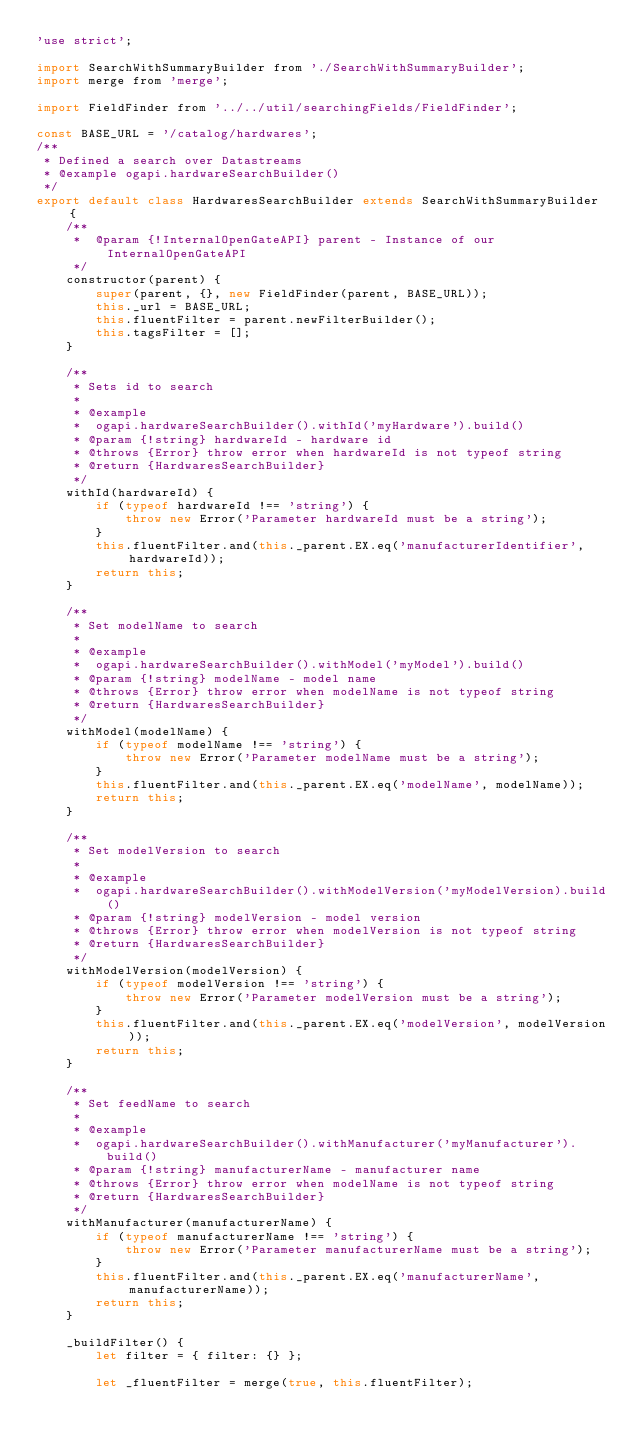Convert code to text. <code><loc_0><loc_0><loc_500><loc_500><_JavaScript_>'use strict';

import SearchWithSummaryBuilder from './SearchWithSummaryBuilder';
import merge from 'merge';

import FieldFinder from '../../util/searchingFields/FieldFinder';

const BASE_URL = '/catalog/hardwares';
/**
 * Defined a search over Datastreams	
 * @example ogapi.hardwareSearchBuilder()
 */
export default class HardwaresSearchBuilder extends SearchWithSummaryBuilder {
    /**
     *	@param {!InternalOpenGateAPI} parent - Instance of our InternalOpenGateAPI
     */
    constructor(parent) {
        super(parent, {}, new FieldFinder(parent, BASE_URL));
        this._url = BASE_URL;
        this.fluentFilter = parent.newFilterBuilder();
        this.tagsFilter = [];
    }

    /**
     * Sets id to search
     *
     * @example
     *	ogapi.hardwareSearchBuilder().withId('myHardware').build()
     * @param {!string} hardwareId - hardware id
     * @throws {Error} throw error when hardwareId is not typeof string
     * @return {HardwaresSearchBuilder} 
     */
    withId(hardwareId) {
        if (typeof hardwareId !== 'string') {
            throw new Error('Parameter hardwareId must be a string');
        }
        this.fluentFilter.and(this._parent.EX.eq('manufacturerIdentifier', hardwareId));
        return this;
    }

    /**
     * Set modelName to search
     *
     * @example
     *	ogapi.hardwareSearchBuilder().withModel('myModel').build()
     * @param {!string} modelName - model name
     * @throws {Error} throw error when modelName is not typeof string
     * @return {HardwaresSearchBuilder} 
     */
    withModel(modelName) {
        if (typeof modelName !== 'string') {
            throw new Error('Parameter modelName must be a string');
        }
        this.fluentFilter.and(this._parent.EX.eq('modelName', modelName));
        return this;
    }

    /**
     * Set modelVersion to search
     *
     * @example
     *	ogapi.hardwareSearchBuilder().withModelVersion('myModelVersion).build()
     * @param {!string} modelVersion - model version
     * @throws {Error} throw error when modelVersion is not typeof string
     * @return {HardwaresSearchBuilder} 
     */
    withModelVersion(modelVersion) {
        if (typeof modelVersion !== 'string') {
            throw new Error('Parameter modelVersion must be a string');
        }
        this.fluentFilter.and(this._parent.EX.eq('modelVersion', modelVersion));
        return this;
    }

    /**
     * Set feedName to search
     *
     * @example
     *	ogapi.hardwareSearchBuilder().withManufacturer('myManufacturer').build()
     * @param {!string} manufacturerName - manufacturer name
     * @throws {Error} throw error when modelName is not typeof string
     * @return {HardwaresSearchBuilder} 
     */
    withManufacturer(manufacturerName) {
        if (typeof manufacturerName !== 'string') {
            throw new Error('Parameter manufacturerName must be a string');
        }
        this.fluentFilter.and(this._parent.EX.eq('manufacturerName', manufacturerName));
        return this;
    }

    _buildFilter() {
        let filter = { filter: {} };

        let _fluentFilter = merge(true, this.fluentFilter);</code> 